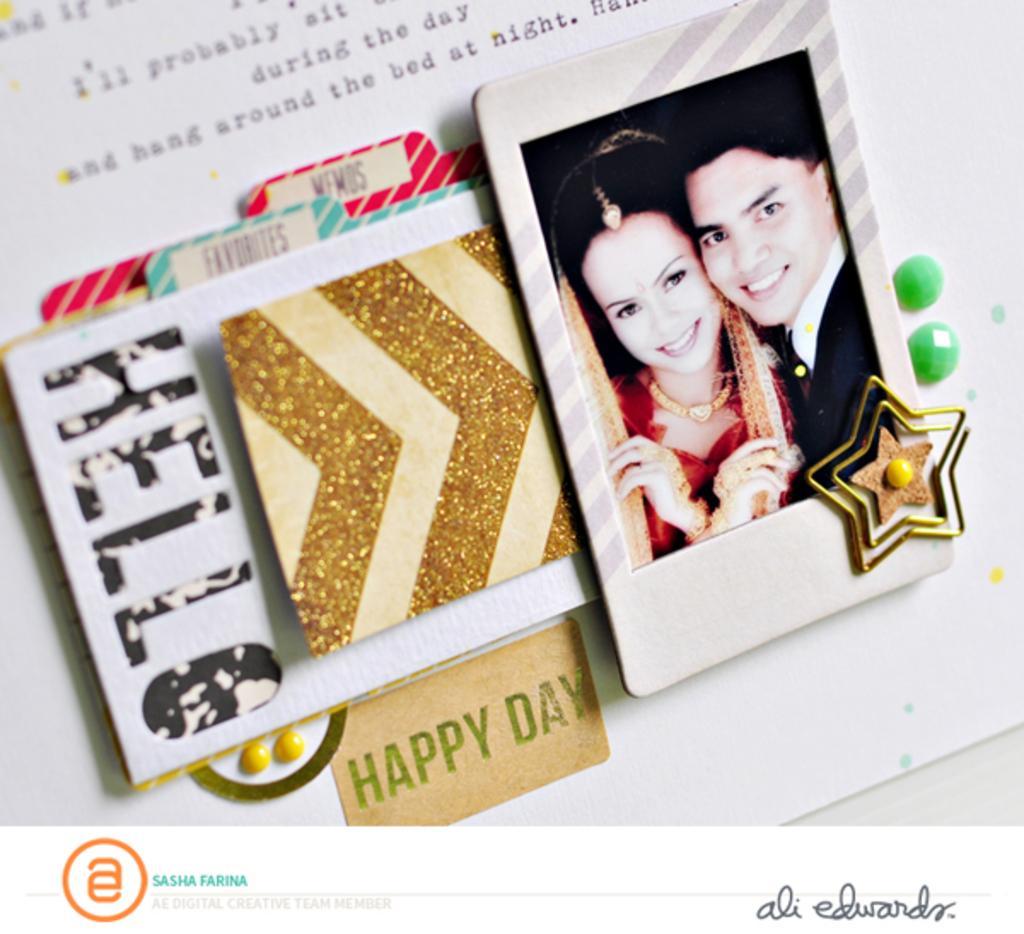Please provide a concise description of this image. In this picture we can see a greeting card, there is some text at the top of the picture, we can see picture of a man and a woman here, at the left bottom there is a logo. 